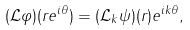Convert formula to latex. <formula><loc_0><loc_0><loc_500><loc_500>( \mathcal { L } \varphi ) ( r e ^ { i \theta } ) = ( \mathcal { L } _ { k } \psi ) ( r ) e ^ { i k \theta } ,</formula> 